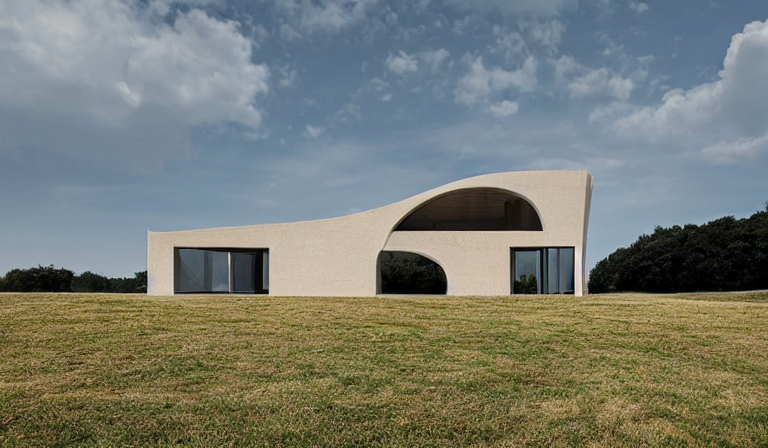How does this building integrate with the environment? The building's low-rise design, organic shapes, and large windows suggest an architectural intention to harmonize with the landscape. The earth-toned colors complement the greenery, and the structure's openness invites interaction between indoor and outdoor spaces. 